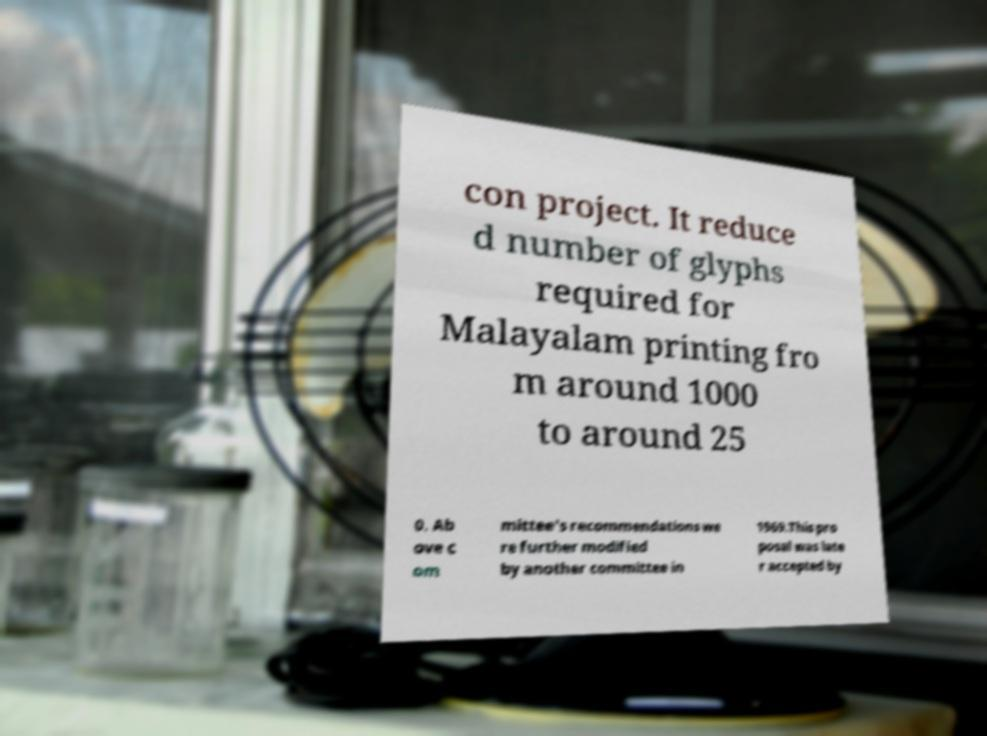Can you accurately transcribe the text from the provided image for me? con project. It reduce d number of glyphs required for Malayalam printing fro m around 1000 to around 25 0. Ab ove c om mittee's recommendations we re further modified by another committee in 1969.This pro posal was late r accepted by 